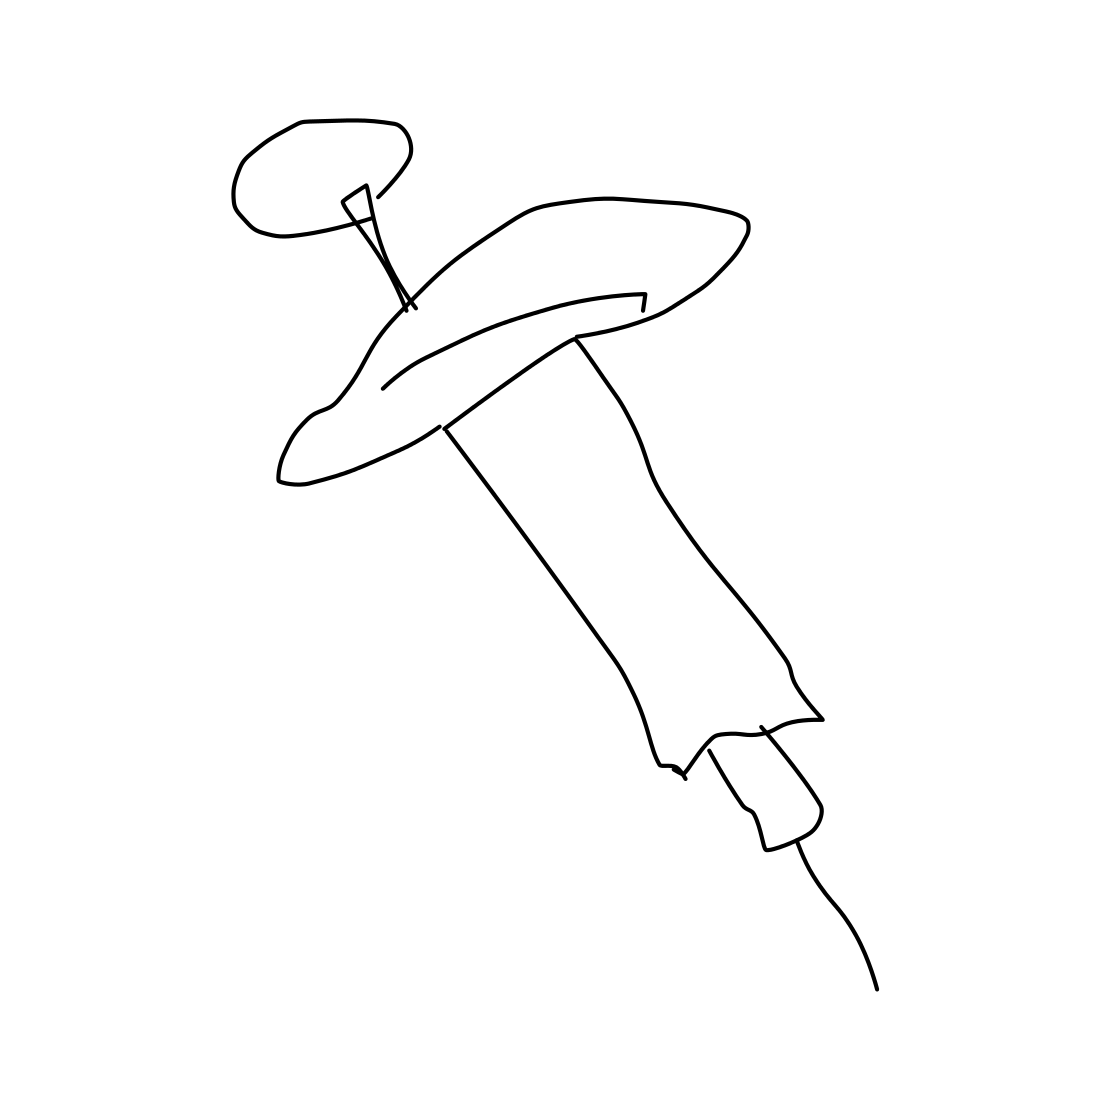Could you estimate the size of this syringe? Without a scale reference, it's difficult to estimate the exact size. However, syringes typically range from 0.5 to 60 milliliters. This one appears to be of a standard size, possibly used for common medical procedures. 